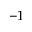<formula> <loc_0><loc_0><loc_500><loc_500>- 1</formula> 